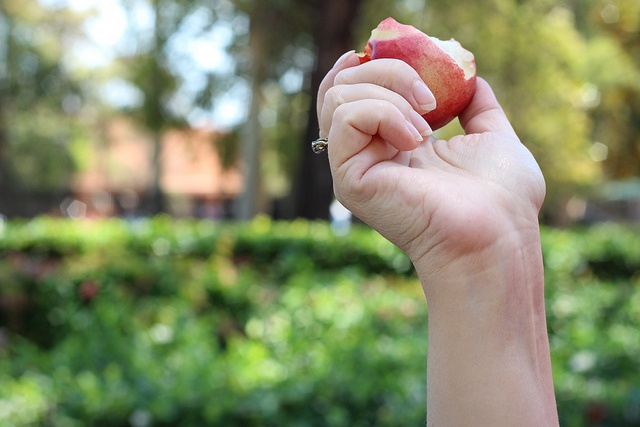Describe the objects in this image and their specific colors. I can see people in gray, darkgray, lightgray, tan, and pink tones and apple in gray, lightgray, lightpink, brown, and salmon tones in this image. 